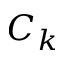Convert formula to latex. <formula><loc_0><loc_0><loc_500><loc_500>C _ { k }</formula> 